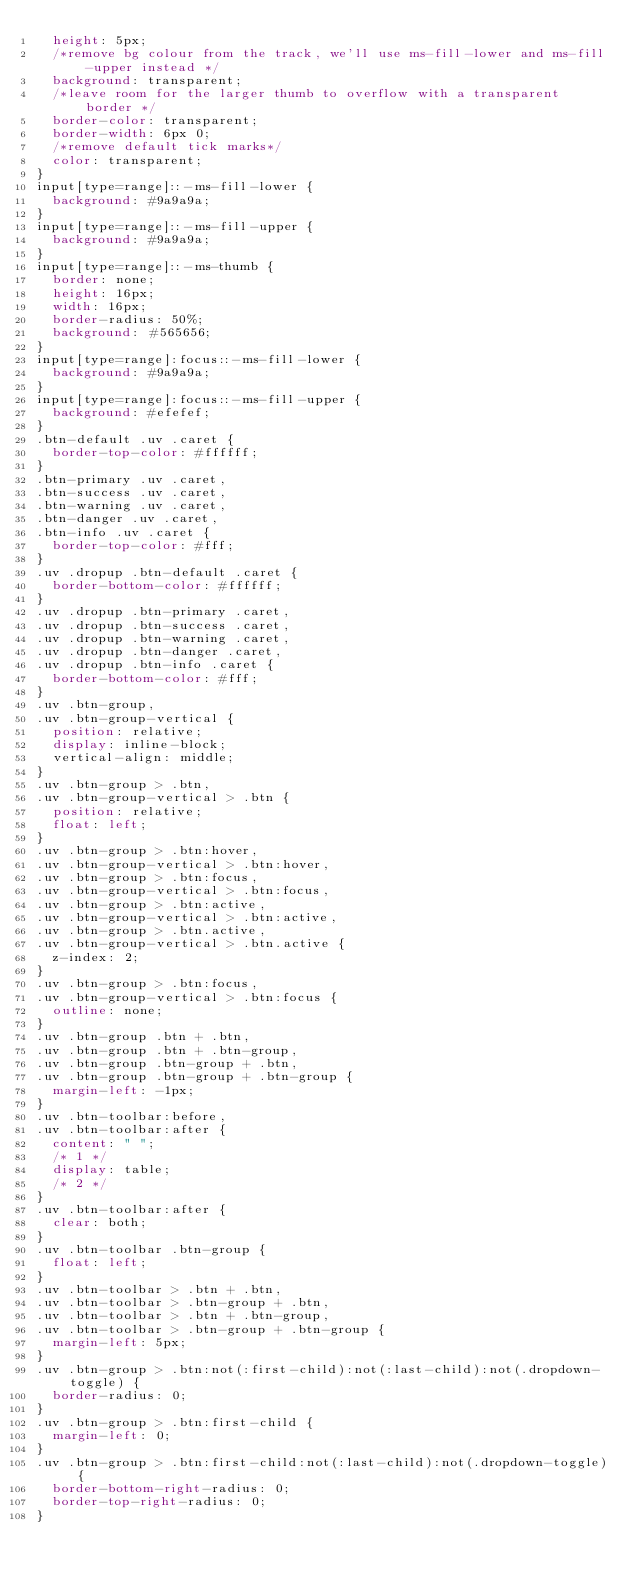<code> <loc_0><loc_0><loc_500><loc_500><_CSS_>  height: 5px;
  /*remove bg colour from the track, we'll use ms-fill-lower and ms-fill-upper instead */
  background: transparent;
  /*leave room for the larger thumb to overflow with a transparent border */
  border-color: transparent;
  border-width: 6px 0;
  /*remove default tick marks*/
  color: transparent;
}
input[type=range]::-ms-fill-lower {
  background: #9a9a9a;
}
input[type=range]::-ms-fill-upper {
  background: #9a9a9a;
}
input[type=range]::-ms-thumb {
  border: none;
  height: 16px;
  width: 16px;
  border-radius: 50%;
  background: #565656;
}
input[type=range]:focus::-ms-fill-lower {
  background: #9a9a9a;
}
input[type=range]:focus::-ms-fill-upper {
  background: #efefef;
}
.btn-default .uv .caret {
  border-top-color: #ffffff;
}
.btn-primary .uv .caret,
.btn-success .uv .caret,
.btn-warning .uv .caret,
.btn-danger .uv .caret,
.btn-info .uv .caret {
  border-top-color: #fff;
}
.uv .dropup .btn-default .caret {
  border-bottom-color: #ffffff;
}
.uv .dropup .btn-primary .caret,
.uv .dropup .btn-success .caret,
.uv .dropup .btn-warning .caret,
.uv .dropup .btn-danger .caret,
.uv .dropup .btn-info .caret {
  border-bottom-color: #fff;
}
.uv .btn-group,
.uv .btn-group-vertical {
  position: relative;
  display: inline-block;
  vertical-align: middle;
}
.uv .btn-group > .btn,
.uv .btn-group-vertical > .btn {
  position: relative;
  float: left;
}
.uv .btn-group > .btn:hover,
.uv .btn-group-vertical > .btn:hover,
.uv .btn-group > .btn:focus,
.uv .btn-group-vertical > .btn:focus,
.uv .btn-group > .btn:active,
.uv .btn-group-vertical > .btn:active,
.uv .btn-group > .btn.active,
.uv .btn-group-vertical > .btn.active {
  z-index: 2;
}
.uv .btn-group > .btn:focus,
.uv .btn-group-vertical > .btn:focus {
  outline: none;
}
.uv .btn-group .btn + .btn,
.uv .btn-group .btn + .btn-group,
.uv .btn-group .btn-group + .btn,
.uv .btn-group .btn-group + .btn-group {
  margin-left: -1px;
}
.uv .btn-toolbar:before,
.uv .btn-toolbar:after {
  content: " ";
  /* 1 */
  display: table;
  /* 2 */
}
.uv .btn-toolbar:after {
  clear: both;
}
.uv .btn-toolbar .btn-group {
  float: left;
}
.uv .btn-toolbar > .btn + .btn,
.uv .btn-toolbar > .btn-group + .btn,
.uv .btn-toolbar > .btn + .btn-group,
.uv .btn-toolbar > .btn-group + .btn-group {
  margin-left: 5px;
}
.uv .btn-group > .btn:not(:first-child):not(:last-child):not(.dropdown-toggle) {
  border-radius: 0;
}
.uv .btn-group > .btn:first-child {
  margin-left: 0;
}
.uv .btn-group > .btn:first-child:not(:last-child):not(.dropdown-toggle) {
  border-bottom-right-radius: 0;
  border-top-right-radius: 0;
}</code> 